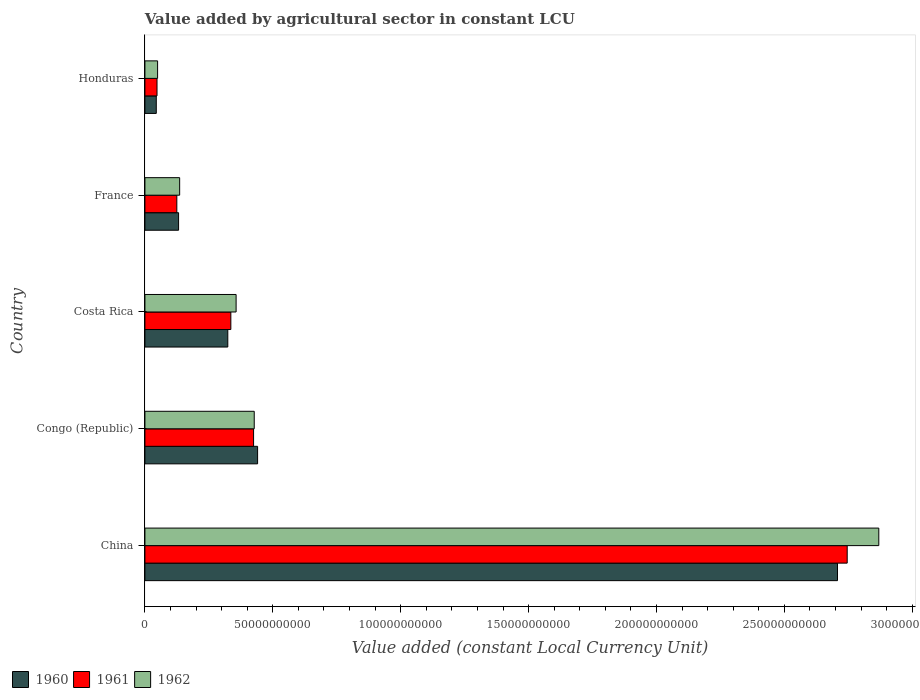How many different coloured bars are there?
Offer a very short reply. 3. Are the number of bars on each tick of the Y-axis equal?
Your answer should be very brief. Yes. How many bars are there on the 3rd tick from the top?
Your response must be concise. 3. In how many cases, is the number of bars for a given country not equal to the number of legend labels?
Your response must be concise. 0. What is the value added by agricultural sector in 1962 in France?
Offer a terse response. 1.36e+1. Across all countries, what is the maximum value added by agricultural sector in 1962?
Offer a terse response. 2.87e+11. Across all countries, what is the minimum value added by agricultural sector in 1961?
Provide a short and direct response. 4.73e+09. In which country was the value added by agricultural sector in 1961 minimum?
Your answer should be compact. Honduras. What is the total value added by agricultural sector in 1961 in the graph?
Make the answer very short. 3.68e+11. What is the difference between the value added by agricultural sector in 1962 in Congo (Republic) and that in France?
Your answer should be compact. 2.92e+1. What is the difference between the value added by agricultural sector in 1960 in Congo (Republic) and the value added by agricultural sector in 1961 in France?
Ensure brevity in your answer.  3.16e+1. What is the average value added by agricultural sector in 1960 per country?
Your response must be concise. 7.30e+1. What is the difference between the value added by agricultural sector in 1961 and value added by agricultural sector in 1960 in China?
Give a very brief answer. 3.79e+09. What is the ratio of the value added by agricultural sector in 1962 in Congo (Republic) to that in Costa Rica?
Provide a succinct answer. 1.2. Is the difference between the value added by agricultural sector in 1961 in France and Honduras greater than the difference between the value added by agricultural sector in 1960 in France and Honduras?
Your answer should be very brief. No. What is the difference between the highest and the second highest value added by agricultural sector in 1961?
Ensure brevity in your answer.  2.32e+11. What is the difference between the highest and the lowest value added by agricultural sector in 1962?
Give a very brief answer. 2.82e+11. Is the sum of the value added by agricultural sector in 1962 in Congo (Republic) and Costa Rica greater than the maximum value added by agricultural sector in 1961 across all countries?
Offer a very short reply. No. Does the graph contain grids?
Give a very brief answer. No. Where does the legend appear in the graph?
Provide a short and direct response. Bottom left. How many legend labels are there?
Your answer should be compact. 3. What is the title of the graph?
Give a very brief answer. Value added by agricultural sector in constant LCU. Does "2005" appear as one of the legend labels in the graph?
Ensure brevity in your answer.  No. What is the label or title of the X-axis?
Your answer should be compact. Value added (constant Local Currency Unit). What is the Value added (constant Local Currency Unit) in 1960 in China?
Provide a succinct answer. 2.71e+11. What is the Value added (constant Local Currency Unit) in 1961 in China?
Offer a terse response. 2.75e+11. What is the Value added (constant Local Currency Unit) in 1962 in China?
Provide a short and direct response. 2.87e+11. What is the Value added (constant Local Currency Unit) in 1960 in Congo (Republic)?
Keep it short and to the point. 4.41e+1. What is the Value added (constant Local Currency Unit) in 1961 in Congo (Republic)?
Provide a short and direct response. 4.25e+1. What is the Value added (constant Local Currency Unit) of 1962 in Congo (Republic)?
Your response must be concise. 4.27e+1. What is the Value added (constant Local Currency Unit) of 1960 in Costa Rica?
Give a very brief answer. 3.24e+1. What is the Value added (constant Local Currency Unit) in 1961 in Costa Rica?
Ensure brevity in your answer.  3.36e+1. What is the Value added (constant Local Currency Unit) in 1962 in Costa Rica?
Offer a terse response. 3.57e+1. What is the Value added (constant Local Currency Unit) in 1960 in France?
Give a very brief answer. 1.32e+1. What is the Value added (constant Local Currency Unit) in 1961 in France?
Give a very brief answer. 1.25e+1. What is the Value added (constant Local Currency Unit) in 1962 in France?
Your response must be concise. 1.36e+1. What is the Value added (constant Local Currency Unit) of 1960 in Honduras?
Provide a succinct answer. 4.44e+09. What is the Value added (constant Local Currency Unit) in 1961 in Honduras?
Make the answer very short. 4.73e+09. What is the Value added (constant Local Currency Unit) of 1962 in Honduras?
Provide a short and direct response. 4.96e+09. Across all countries, what is the maximum Value added (constant Local Currency Unit) in 1960?
Offer a very short reply. 2.71e+11. Across all countries, what is the maximum Value added (constant Local Currency Unit) of 1961?
Give a very brief answer. 2.75e+11. Across all countries, what is the maximum Value added (constant Local Currency Unit) in 1962?
Ensure brevity in your answer.  2.87e+11. Across all countries, what is the minimum Value added (constant Local Currency Unit) of 1960?
Offer a terse response. 4.44e+09. Across all countries, what is the minimum Value added (constant Local Currency Unit) in 1961?
Offer a very short reply. 4.73e+09. Across all countries, what is the minimum Value added (constant Local Currency Unit) of 1962?
Offer a terse response. 4.96e+09. What is the total Value added (constant Local Currency Unit) in 1960 in the graph?
Your response must be concise. 3.65e+11. What is the total Value added (constant Local Currency Unit) of 1961 in the graph?
Provide a short and direct response. 3.68e+11. What is the total Value added (constant Local Currency Unit) of 1962 in the graph?
Your answer should be compact. 3.84e+11. What is the difference between the Value added (constant Local Currency Unit) in 1960 in China and that in Congo (Republic)?
Your response must be concise. 2.27e+11. What is the difference between the Value added (constant Local Currency Unit) of 1961 in China and that in Congo (Republic)?
Make the answer very short. 2.32e+11. What is the difference between the Value added (constant Local Currency Unit) in 1962 in China and that in Congo (Republic)?
Your answer should be very brief. 2.44e+11. What is the difference between the Value added (constant Local Currency Unit) in 1960 in China and that in Costa Rica?
Offer a terse response. 2.38e+11. What is the difference between the Value added (constant Local Currency Unit) of 1961 in China and that in Costa Rica?
Give a very brief answer. 2.41e+11. What is the difference between the Value added (constant Local Currency Unit) of 1962 in China and that in Costa Rica?
Your answer should be very brief. 2.51e+11. What is the difference between the Value added (constant Local Currency Unit) of 1960 in China and that in France?
Provide a short and direct response. 2.58e+11. What is the difference between the Value added (constant Local Currency Unit) in 1961 in China and that in France?
Give a very brief answer. 2.62e+11. What is the difference between the Value added (constant Local Currency Unit) of 1962 in China and that in France?
Your response must be concise. 2.73e+11. What is the difference between the Value added (constant Local Currency Unit) in 1960 in China and that in Honduras?
Ensure brevity in your answer.  2.66e+11. What is the difference between the Value added (constant Local Currency Unit) of 1961 in China and that in Honduras?
Make the answer very short. 2.70e+11. What is the difference between the Value added (constant Local Currency Unit) of 1962 in China and that in Honduras?
Provide a short and direct response. 2.82e+11. What is the difference between the Value added (constant Local Currency Unit) of 1960 in Congo (Republic) and that in Costa Rica?
Your answer should be very brief. 1.17e+1. What is the difference between the Value added (constant Local Currency Unit) of 1961 in Congo (Republic) and that in Costa Rica?
Offer a terse response. 8.89e+09. What is the difference between the Value added (constant Local Currency Unit) of 1962 in Congo (Republic) and that in Costa Rica?
Your answer should be compact. 7.08e+09. What is the difference between the Value added (constant Local Currency Unit) in 1960 in Congo (Republic) and that in France?
Provide a short and direct response. 3.09e+1. What is the difference between the Value added (constant Local Currency Unit) in 1961 in Congo (Republic) and that in France?
Ensure brevity in your answer.  3.00e+1. What is the difference between the Value added (constant Local Currency Unit) in 1962 in Congo (Republic) and that in France?
Keep it short and to the point. 2.92e+1. What is the difference between the Value added (constant Local Currency Unit) of 1960 in Congo (Republic) and that in Honduras?
Keep it short and to the point. 3.96e+1. What is the difference between the Value added (constant Local Currency Unit) of 1961 in Congo (Republic) and that in Honduras?
Your answer should be compact. 3.78e+1. What is the difference between the Value added (constant Local Currency Unit) of 1962 in Congo (Republic) and that in Honduras?
Offer a terse response. 3.78e+1. What is the difference between the Value added (constant Local Currency Unit) of 1960 in Costa Rica and that in France?
Keep it short and to the point. 1.92e+1. What is the difference between the Value added (constant Local Currency Unit) of 1961 in Costa Rica and that in France?
Keep it short and to the point. 2.11e+1. What is the difference between the Value added (constant Local Currency Unit) of 1962 in Costa Rica and that in France?
Your answer should be compact. 2.21e+1. What is the difference between the Value added (constant Local Currency Unit) of 1960 in Costa Rica and that in Honduras?
Provide a succinct answer. 2.80e+1. What is the difference between the Value added (constant Local Currency Unit) in 1961 in Costa Rica and that in Honduras?
Offer a very short reply. 2.89e+1. What is the difference between the Value added (constant Local Currency Unit) in 1962 in Costa Rica and that in Honduras?
Provide a succinct answer. 3.07e+1. What is the difference between the Value added (constant Local Currency Unit) in 1960 in France and that in Honduras?
Offer a terse response. 8.72e+09. What is the difference between the Value added (constant Local Currency Unit) in 1961 in France and that in Honduras?
Your response must be concise. 7.74e+09. What is the difference between the Value added (constant Local Currency Unit) in 1962 in France and that in Honduras?
Your answer should be very brief. 8.63e+09. What is the difference between the Value added (constant Local Currency Unit) of 1960 in China and the Value added (constant Local Currency Unit) of 1961 in Congo (Republic)?
Your answer should be very brief. 2.28e+11. What is the difference between the Value added (constant Local Currency Unit) of 1960 in China and the Value added (constant Local Currency Unit) of 1962 in Congo (Republic)?
Ensure brevity in your answer.  2.28e+11. What is the difference between the Value added (constant Local Currency Unit) of 1961 in China and the Value added (constant Local Currency Unit) of 1962 in Congo (Republic)?
Provide a short and direct response. 2.32e+11. What is the difference between the Value added (constant Local Currency Unit) in 1960 in China and the Value added (constant Local Currency Unit) in 1961 in Costa Rica?
Offer a terse response. 2.37e+11. What is the difference between the Value added (constant Local Currency Unit) of 1960 in China and the Value added (constant Local Currency Unit) of 1962 in Costa Rica?
Offer a very short reply. 2.35e+11. What is the difference between the Value added (constant Local Currency Unit) in 1961 in China and the Value added (constant Local Currency Unit) in 1962 in Costa Rica?
Make the answer very short. 2.39e+11. What is the difference between the Value added (constant Local Currency Unit) in 1960 in China and the Value added (constant Local Currency Unit) in 1961 in France?
Keep it short and to the point. 2.58e+11. What is the difference between the Value added (constant Local Currency Unit) in 1960 in China and the Value added (constant Local Currency Unit) in 1962 in France?
Your answer should be very brief. 2.57e+11. What is the difference between the Value added (constant Local Currency Unit) in 1961 in China and the Value added (constant Local Currency Unit) in 1962 in France?
Your answer should be very brief. 2.61e+11. What is the difference between the Value added (constant Local Currency Unit) in 1960 in China and the Value added (constant Local Currency Unit) in 1961 in Honduras?
Ensure brevity in your answer.  2.66e+11. What is the difference between the Value added (constant Local Currency Unit) in 1960 in China and the Value added (constant Local Currency Unit) in 1962 in Honduras?
Provide a short and direct response. 2.66e+11. What is the difference between the Value added (constant Local Currency Unit) of 1961 in China and the Value added (constant Local Currency Unit) of 1962 in Honduras?
Provide a short and direct response. 2.70e+11. What is the difference between the Value added (constant Local Currency Unit) of 1960 in Congo (Republic) and the Value added (constant Local Currency Unit) of 1961 in Costa Rica?
Ensure brevity in your answer.  1.05e+1. What is the difference between the Value added (constant Local Currency Unit) of 1960 in Congo (Republic) and the Value added (constant Local Currency Unit) of 1962 in Costa Rica?
Your answer should be very brief. 8.40e+09. What is the difference between the Value added (constant Local Currency Unit) of 1961 in Congo (Republic) and the Value added (constant Local Currency Unit) of 1962 in Costa Rica?
Give a very brief answer. 6.83e+09. What is the difference between the Value added (constant Local Currency Unit) of 1960 in Congo (Republic) and the Value added (constant Local Currency Unit) of 1961 in France?
Offer a very short reply. 3.16e+1. What is the difference between the Value added (constant Local Currency Unit) of 1960 in Congo (Republic) and the Value added (constant Local Currency Unit) of 1962 in France?
Offer a very short reply. 3.05e+1. What is the difference between the Value added (constant Local Currency Unit) of 1961 in Congo (Republic) and the Value added (constant Local Currency Unit) of 1962 in France?
Make the answer very short. 2.89e+1. What is the difference between the Value added (constant Local Currency Unit) in 1960 in Congo (Republic) and the Value added (constant Local Currency Unit) in 1961 in Honduras?
Your response must be concise. 3.93e+1. What is the difference between the Value added (constant Local Currency Unit) in 1960 in Congo (Republic) and the Value added (constant Local Currency Unit) in 1962 in Honduras?
Keep it short and to the point. 3.91e+1. What is the difference between the Value added (constant Local Currency Unit) in 1961 in Congo (Republic) and the Value added (constant Local Currency Unit) in 1962 in Honduras?
Make the answer very short. 3.75e+1. What is the difference between the Value added (constant Local Currency Unit) in 1960 in Costa Rica and the Value added (constant Local Currency Unit) in 1961 in France?
Offer a terse response. 1.99e+1. What is the difference between the Value added (constant Local Currency Unit) in 1960 in Costa Rica and the Value added (constant Local Currency Unit) in 1962 in France?
Ensure brevity in your answer.  1.88e+1. What is the difference between the Value added (constant Local Currency Unit) in 1961 in Costa Rica and the Value added (constant Local Currency Unit) in 1962 in France?
Provide a succinct answer. 2.00e+1. What is the difference between the Value added (constant Local Currency Unit) in 1960 in Costa Rica and the Value added (constant Local Currency Unit) in 1961 in Honduras?
Ensure brevity in your answer.  2.77e+1. What is the difference between the Value added (constant Local Currency Unit) of 1960 in Costa Rica and the Value added (constant Local Currency Unit) of 1962 in Honduras?
Offer a very short reply. 2.74e+1. What is the difference between the Value added (constant Local Currency Unit) of 1961 in Costa Rica and the Value added (constant Local Currency Unit) of 1962 in Honduras?
Give a very brief answer. 2.86e+1. What is the difference between the Value added (constant Local Currency Unit) in 1960 in France and the Value added (constant Local Currency Unit) in 1961 in Honduras?
Your response must be concise. 8.43e+09. What is the difference between the Value added (constant Local Currency Unit) in 1960 in France and the Value added (constant Local Currency Unit) in 1962 in Honduras?
Offer a terse response. 8.20e+09. What is the difference between the Value added (constant Local Currency Unit) in 1961 in France and the Value added (constant Local Currency Unit) in 1962 in Honduras?
Your response must be concise. 7.52e+09. What is the average Value added (constant Local Currency Unit) in 1960 per country?
Ensure brevity in your answer.  7.30e+1. What is the average Value added (constant Local Currency Unit) of 1961 per country?
Ensure brevity in your answer.  7.36e+1. What is the average Value added (constant Local Currency Unit) of 1962 per country?
Ensure brevity in your answer.  7.68e+1. What is the difference between the Value added (constant Local Currency Unit) of 1960 and Value added (constant Local Currency Unit) of 1961 in China?
Ensure brevity in your answer.  -3.79e+09. What is the difference between the Value added (constant Local Currency Unit) in 1960 and Value added (constant Local Currency Unit) in 1962 in China?
Your response must be concise. -1.61e+1. What is the difference between the Value added (constant Local Currency Unit) of 1961 and Value added (constant Local Currency Unit) of 1962 in China?
Make the answer very short. -1.24e+1. What is the difference between the Value added (constant Local Currency Unit) of 1960 and Value added (constant Local Currency Unit) of 1961 in Congo (Republic)?
Give a very brief answer. 1.57e+09. What is the difference between the Value added (constant Local Currency Unit) in 1960 and Value added (constant Local Currency Unit) in 1962 in Congo (Republic)?
Your answer should be compact. 1.32e+09. What is the difference between the Value added (constant Local Currency Unit) in 1961 and Value added (constant Local Currency Unit) in 1962 in Congo (Republic)?
Make the answer very short. -2.56e+08. What is the difference between the Value added (constant Local Currency Unit) of 1960 and Value added (constant Local Currency Unit) of 1961 in Costa Rica?
Offer a very short reply. -1.19e+09. What is the difference between the Value added (constant Local Currency Unit) of 1960 and Value added (constant Local Currency Unit) of 1962 in Costa Rica?
Ensure brevity in your answer.  -3.25e+09. What is the difference between the Value added (constant Local Currency Unit) of 1961 and Value added (constant Local Currency Unit) of 1962 in Costa Rica?
Provide a succinct answer. -2.06e+09. What is the difference between the Value added (constant Local Currency Unit) of 1960 and Value added (constant Local Currency Unit) of 1961 in France?
Keep it short and to the point. 6.84e+08. What is the difference between the Value added (constant Local Currency Unit) in 1960 and Value added (constant Local Currency Unit) in 1962 in France?
Your response must be concise. -4.23e+08. What is the difference between the Value added (constant Local Currency Unit) in 1961 and Value added (constant Local Currency Unit) in 1962 in France?
Keep it short and to the point. -1.11e+09. What is the difference between the Value added (constant Local Currency Unit) in 1960 and Value added (constant Local Currency Unit) in 1961 in Honduras?
Your response must be concise. -2.90e+08. What is the difference between the Value added (constant Local Currency Unit) in 1960 and Value added (constant Local Currency Unit) in 1962 in Honduras?
Offer a terse response. -5.15e+08. What is the difference between the Value added (constant Local Currency Unit) of 1961 and Value added (constant Local Currency Unit) of 1962 in Honduras?
Offer a terse response. -2.25e+08. What is the ratio of the Value added (constant Local Currency Unit) in 1960 in China to that in Congo (Republic)?
Your answer should be very brief. 6.15. What is the ratio of the Value added (constant Local Currency Unit) in 1961 in China to that in Congo (Republic)?
Make the answer very short. 6.46. What is the ratio of the Value added (constant Local Currency Unit) of 1962 in China to that in Congo (Republic)?
Provide a short and direct response. 6.71. What is the ratio of the Value added (constant Local Currency Unit) of 1960 in China to that in Costa Rica?
Offer a terse response. 8.36. What is the ratio of the Value added (constant Local Currency Unit) in 1961 in China to that in Costa Rica?
Offer a very short reply. 8.17. What is the ratio of the Value added (constant Local Currency Unit) of 1962 in China to that in Costa Rica?
Your response must be concise. 8.05. What is the ratio of the Value added (constant Local Currency Unit) of 1960 in China to that in France?
Make the answer very short. 20.58. What is the ratio of the Value added (constant Local Currency Unit) in 1961 in China to that in France?
Your answer should be very brief. 22.01. What is the ratio of the Value added (constant Local Currency Unit) in 1962 in China to that in France?
Your response must be concise. 21.13. What is the ratio of the Value added (constant Local Currency Unit) in 1960 in China to that in Honduras?
Provide a succinct answer. 60.98. What is the ratio of the Value added (constant Local Currency Unit) in 1961 in China to that in Honduras?
Provide a short and direct response. 58.04. What is the ratio of the Value added (constant Local Currency Unit) of 1962 in China to that in Honduras?
Provide a succinct answer. 57.9. What is the ratio of the Value added (constant Local Currency Unit) in 1960 in Congo (Republic) to that in Costa Rica?
Ensure brevity in your answer.  1.36. What is the ratio of the Value added (constant Local Currency Unit) in 1961 in Congo (Republic) to that in Costa Rica?
Keep it short and to the point. 1.26. What is the ratio of the Value added (constant Local Currency Unit) of 1962 in Congo (Republic) to that in Costa Rica?
Provide a succinct answer. 1.2. What is the ratio of the Value added (constant Local Currency Unit) in 1960 in Congo (Republic) to that in France?
Make the answer very short. 3.35. What is the ratio of the Value added (constant Local Currency Unit) of 1961 in Congo (Republic) to that in France?
Your response must be concise. 3.41. What is the ratio of the Value added (constant Local Currency Unit) of 1962 in Congo (Republic) to that in France?
Your response must be concise. 3.15. What is the ratio of the Value added (constant Local Currency Unit) in 1960 in Congo (Republic) to that in Honduras?
Offer a very short reply. 9.92. What is the ratio of the Value added (constant Local Currency Unit) of 1961 in Congo (Republic) to that in Honduras?
Provide a short and direct response. 8.98. What is the ratio of the Value added (constant Local Currency Unit) in 1962 in Congo (Republic) to that in Honduras?
Offer a very short reply. 8.62. What is the ratio of the Value added (constant Local Currency Unit) of 1960 in Costa Rica to that in France?
Provide a succinct answer. 2.46. What is the ratio of the Value added (constant Local Currency Unit) in 1961 in Costa Rica to that in France?
Your answer should be very brief. 2.69. What is the ratio of the Value added (constant Local Currency Unit) of 1962 in Costa Rica to that in France?
Make the answer very short. 2.63. What is the ratio of the Value added (constant Local Currency Unit) in 1960 in Costa Rica to that in Honduras?
Give a very brief answer. 7.3. What is the ratio of the Value added (constant Local Currency Unit) of 1961 in Costa Rica to that in Honduras?
Offer a terse response. 7.1. What is the ratio of the Value added (constant Local Currency Unit) in 1962 in Costa Rica to that in Honduras?
Ensure brevity in your answer.  7.2. What is the ratio of the Value added (constant Local Currency Unit) in 1960 in France to that in Honduras?
Provide a short and direct response. 2.96. What is the ratio of the Value added (constant Local Currency Unit) of 1961 in France to that in Honduras?
Your answer should be compact. 2.64. What is the ratio of the Value added (constant Local Currency Unit) in 1962 in France to that in Honduras?
Offer a terse response. 2.74. What is the difference between the highest and the second highest Value added (constant Local Currency Unit) of 1960?
Your answer should be compact. 2.27e+11. What is the difference between the highest and the second highest Value added (constant Local Currency Unit) in 1961?
Your answer should be very brief. 2.32e+11. What is the difference between the highest and the second highest Value added (constant Local Currency Unit) of 1962?
Make the answer very short. 2.44e+11. What is the difference between the highest and the lowest Value added (constant Local Currency Unit) in 1960?
Keep it short and to the point. 2.66e+11. What is the difference between the highest and the lowest Value added (constant Local Currency Unit) of 1961?
Your response must be concise. 2.70e+11. What is the difference between the highest and the lowest Value added (constant Local Currency Unit) of 1962?
Give a very brief answer. 2.82e+11. 